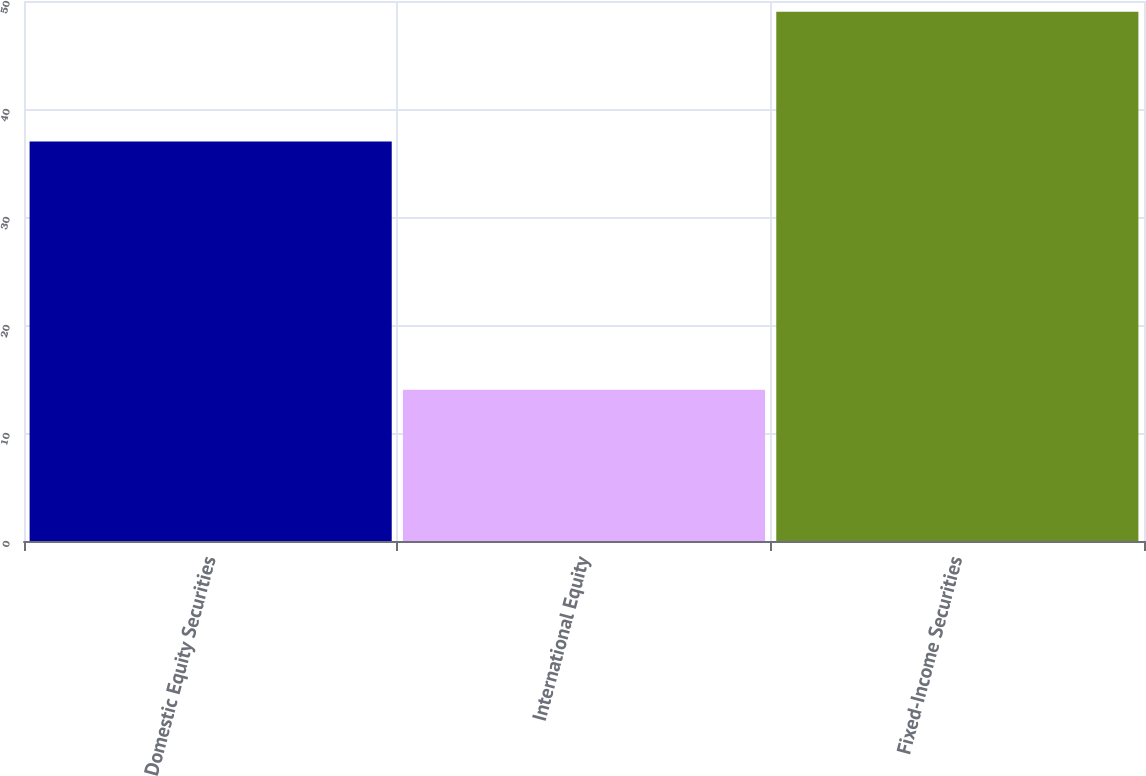Convert chart. <chart><loc_0><loc_0><loc_500><loc_500><bar_chart><fcel>Domestic Equity Securities<fcel>International Equity<fcel>Fixed-Income Securities<nl><fcel>37<fcel>14<fcel>49<nl></chart> 